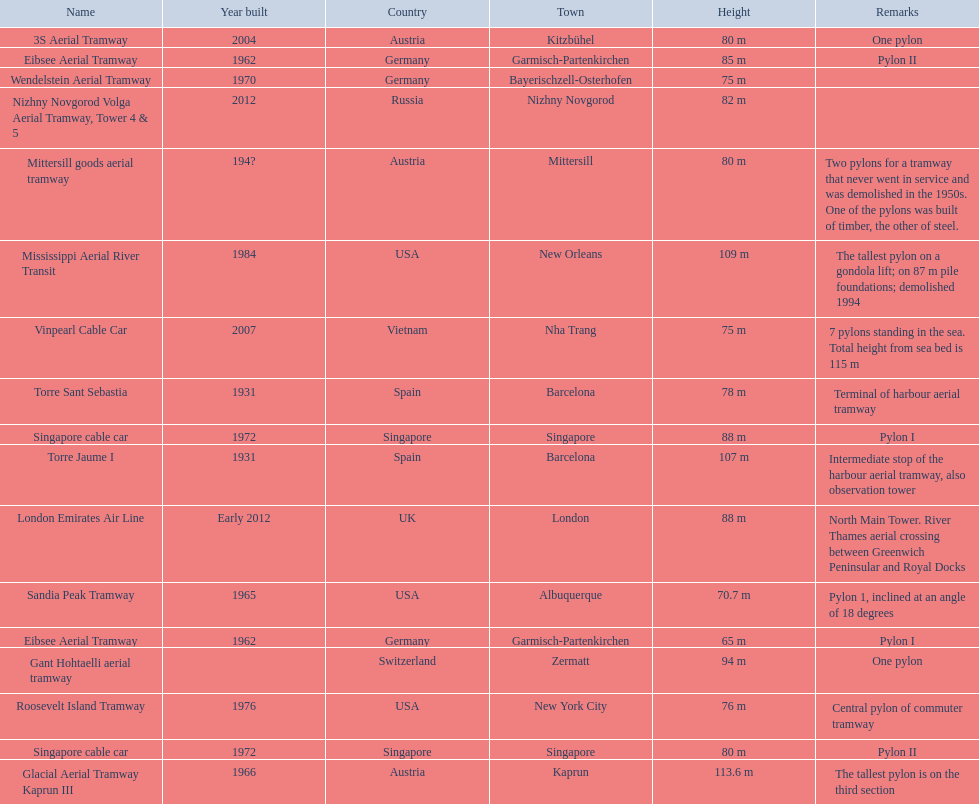Which pylon has the most remarks about it? Mittersill goods aerial tramway. 